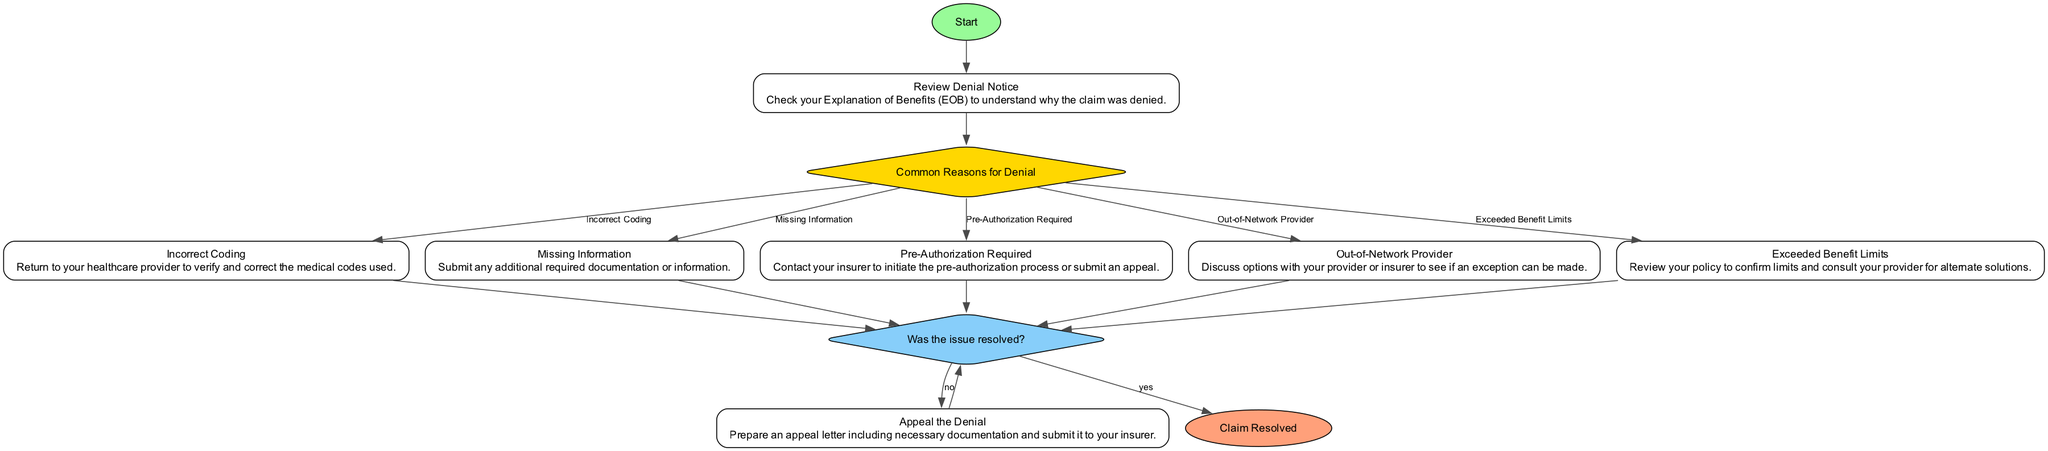What is the first step in the process? The first step in the process is denoted by the "Start" node, which leads to reviewing the denial notice. This node clearly represents the initiation of the entire process.
Answer: Start How many common reasons for denial are listed? The diagram includes a "Common Reasons for Denial" node with five options branching from it. By counting these options, we confirm the total number listed.
Answer: Five What should you do if the denial is due to "Incorrect Coding"? The flow from the "Incorrect Coding" option leads to the process of returning to your healthcare provider to verify and correct the coding used on the claim. This describes the necessary action when faced with this specific denial reason.
Answer: Return to your healthcare provider Which option leads to contacting your insurer? The "Pre-Authorization Required" option connects to the action of contacting your insurer to initiate the necessary pre-authorization process, representing a critical step when that condition is met.
Answer: Pre-Authorization Required What happens after resolving the issue? Once the issue is resolved, the flow indicates that it leads to the "Claim Resolved" node. This indicates the successful outcome of addressing the denial.
Answer: Claim Resolved If the issue is not resolved, what is the next step? If the resolution is not satisfactory (indicated by the "no" option), the process directs you to prepare and submit an appeal to your insurer. This step follows directly from the result of reviewing the resolution status.
Answer: Appeal the Denial Which type of node is "Common Reasons for Denial"? The "Common Reasons for Denial" node is a selection type, visually represented as a diamond shape in the diagram, specific to choices that influence the next steps in the process.
Answer: Select What is the action taken for "Exceeded Benefit Limits"? Following the "Exceeded Benefit Limits" option, the necessary action is to review your policy and consult your provider for alternate solutions, indicating what to do when faced with this particular denial reason.
Answer: Review your policy and consult your provider 